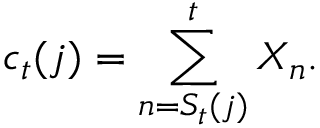<formula> <loc_0><loc_0><loc_500><loc_500>c _ { t } ( j ) = \sum _ { n = S _ { t } ( j ) } ^ { t } X _ { n } .</formula> 